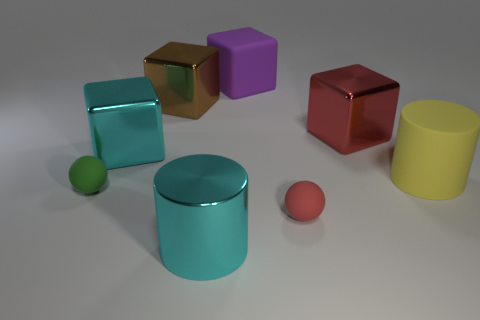Subtract all large cyan shiny cubes. How many cubes are left? 3 Add 1 matte cylinders. How many objects exist? 9 Subtract all cyan cubes. How many cubes are left? 3 Subtract all large red shiny cubes. Subtract all red metal things. How many objects are left? 6 Add 7 red metal cubes. How many red metal cubes are left? 8 Add 6 cyan shiny cylinders. How many cyan shiny cylinders exist? 7 Subtract 1 purple blocks. How many objects are left? 7 Subtract all cylinders. How many objects are left? 6 Subtract all yellow balls. Subtract all cyan cubes. How many balls are left? 2 Subtract all purple cylinders. How many red spheres are left? 1 